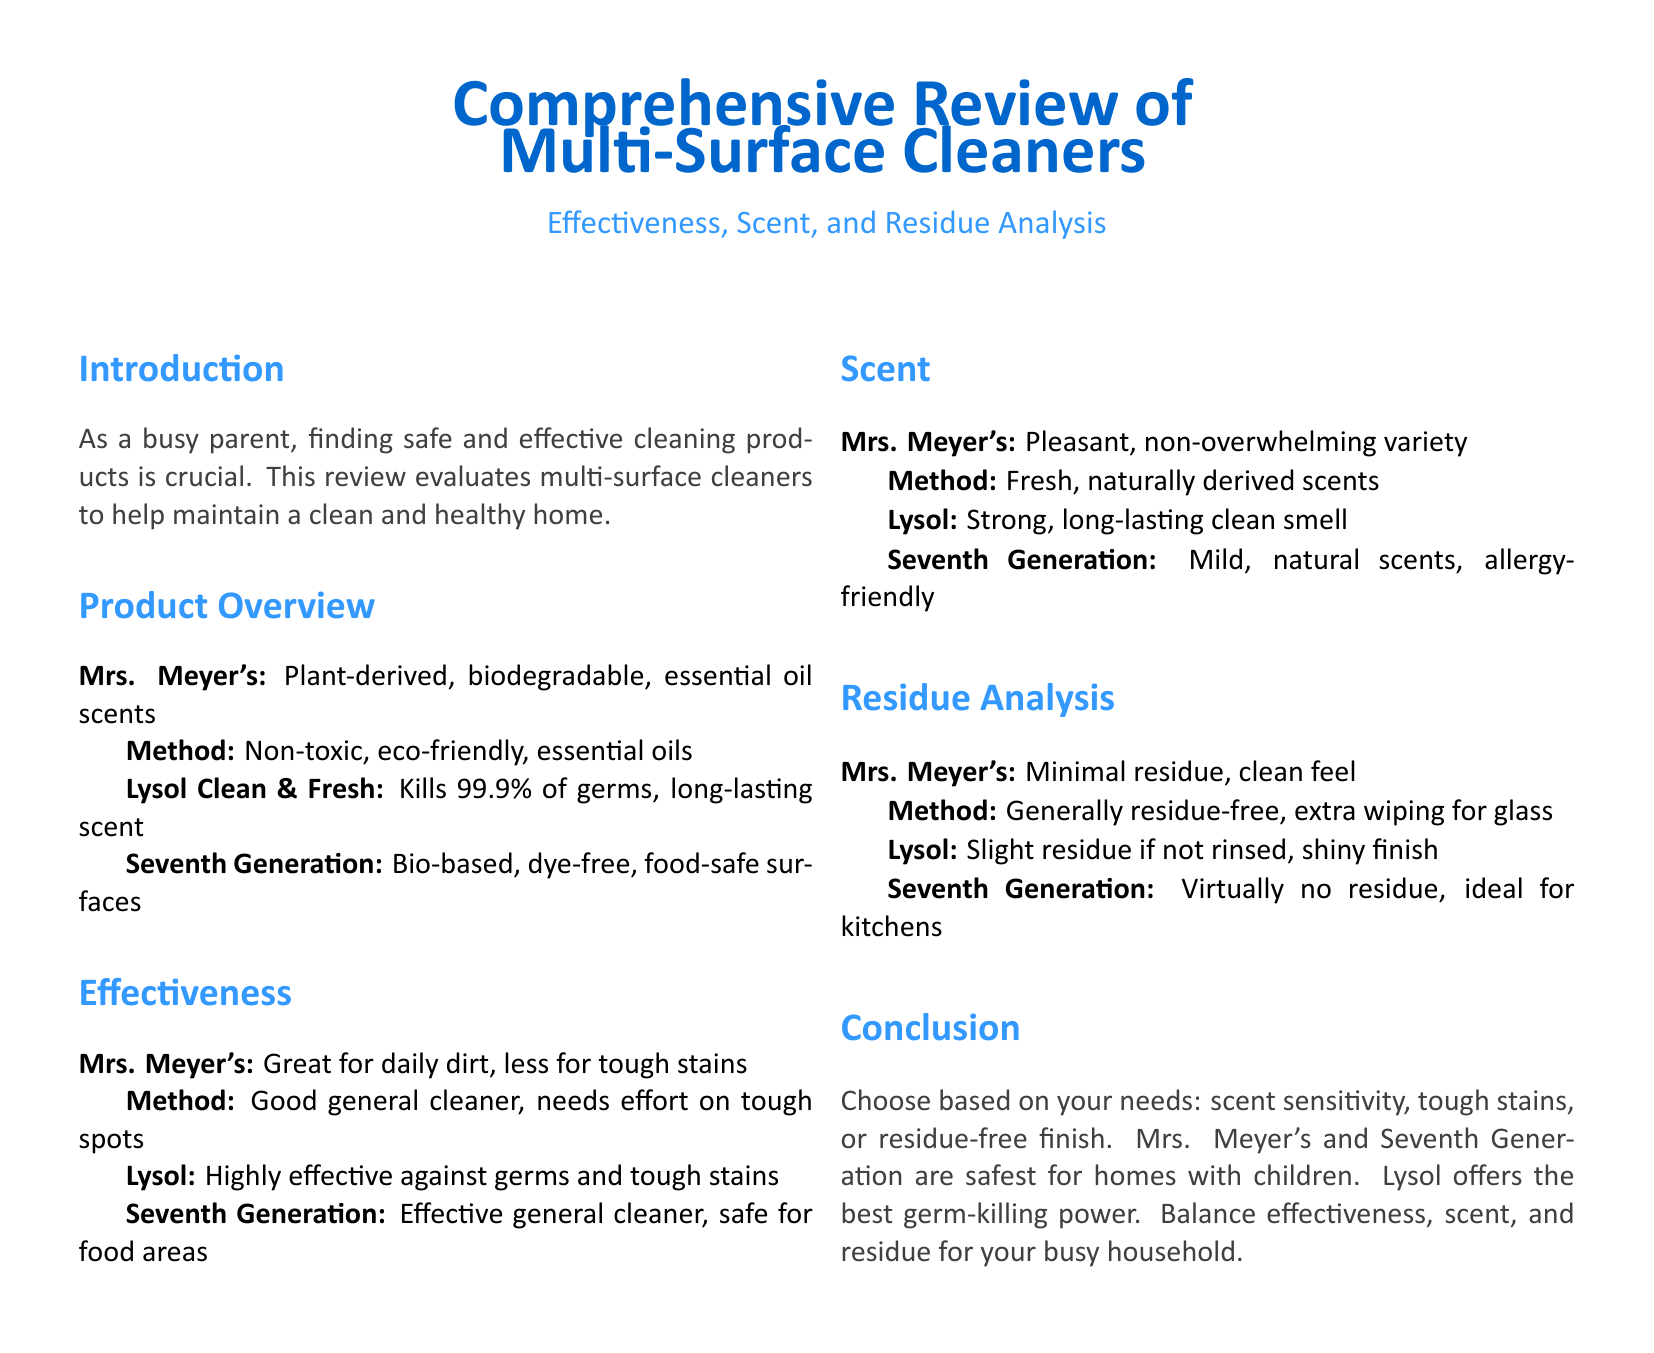What is the main focus of the review? The review evaluates multi-surface cleaners to help maintain a clean and healthy home, particularly for busy parents.
Answer: Safe and effective cleaning products What is the primary cleaning agent in Seventh Generation? Seventh Generation is described as bio-based and dye-free, making it safe for food areas.
Answer: Bio-based, dye-free What is the effectiveness of Lysol Clean & Fresh? Lysol is noted to kill 99.9% of germs and is highly effective against tough stains.
Answer: Highly effective What scent type does Mrs. Meyer's offer? The scent type of Mrs. Meyer's is described as pleasant and non-overwhelming.
Answer: Pleasant, non-overwhelming What type of residue does Seventh Generation leave? Seventh Generation is mentioned to leave virtually no residue, making it ideal for kitchens.
Answer: Virtually no residue How does Method compare in residue analysis? Method is generally residue-free but may require extra wiping for glass surfaces.
Answer: Generally residue-free Which cleaner is recommended for homes with children? Mrs. Meyer's and Seventh Generation are identified as the safest for homes with children.
Answer: Mrs. Meyer's and Seventh Generation What is the scent characteristic of Lysol? Lysol is noted to have a strong and long-lasting clean smell.
Answer: Strong, long-lasting clean smell What is the conclusion regarding choosing cleaning products? The conclusion suggests balancing effectiveness, scent, and residue based on individual needs.
Answer: Balance effectiveness, scent, and residue 